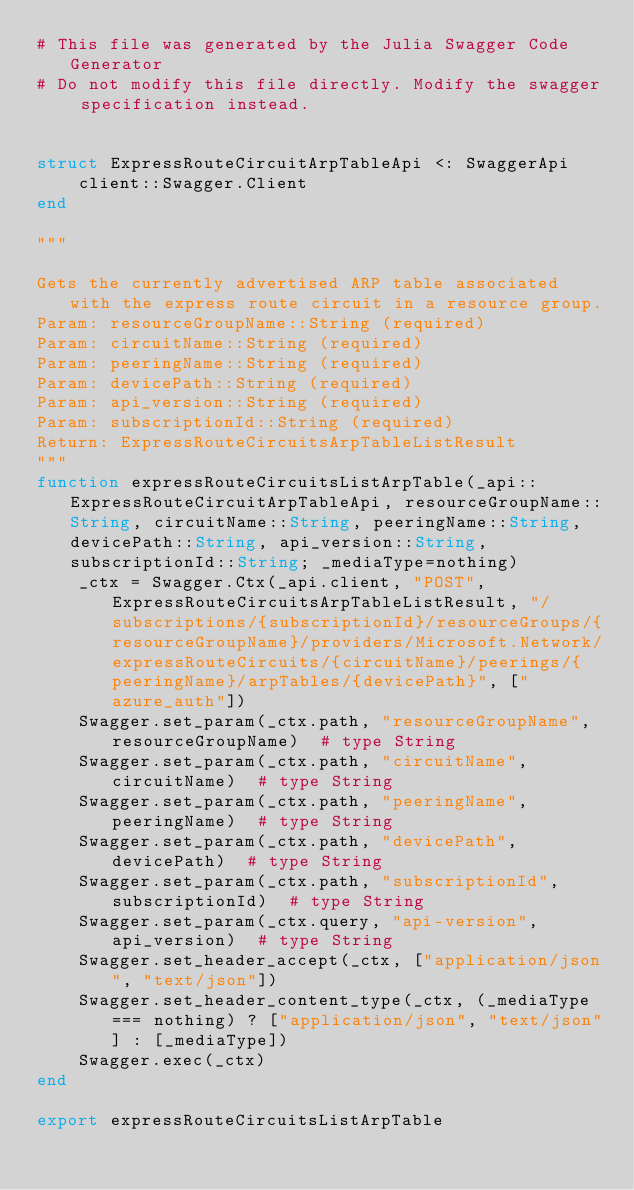<code> <loc_0><loc_0><loc_500><loc_500><_Julia_># This file was generated by the Julia Swagger Code Generator
# Do not modify this file directly. Modify the swagger specification instead.


struct ExpressRouteCircuitArpTableApi <: SwaggerApi
    client::Swagger.Client
end

"""

Gets the currently advertised ARP table associated with the express route circuit in a resource group.
Param: resourceGroupName::String (required)
Param: circuitName::String (required)
Param: peeringName::String (required)
Param: devicePath::String (required)
Param: api_version::String (required)
Param: subscriptionId::String (required)
Return: ExpressRouteCircuitsArpTableListResult
"""
function expressRouteCircuitsListArpTable(_api::ExpressRouteCircuitArpTableApi, resourceGroupName::String, circuitName::String, peeringName::String, devicePath::String, api_version::String, subscriptionId::String; _mediaType=nothing)
    _ctx = Swagger.Ctx(_api.client, "POST", ExpressRouteCircuitsArpTableListResult, "/subscriptions/{subscriptionId}/resourceGroups/{resourceGroupName}/providers/Microsoft.Network/expressRouteCircuits/{circuitName}/peerings/{peeringName}/arpTables/{devicePath}", ["azure_auth"])
    Swagger.set_param(_ctx.path, "resourceGroupName", resourceGroupName)  # type String
    Swagger.set_param(_ctx.path, "circuitName", circuitName)  # type String
    Swagger.set_param(_ctx.path, "peeringName", peeringName)  # type String
    Swagger.set_param(_ctx.path, "devicePath", devicePath)  # type String
    Swagger.set_param(_ctx.path, "subscriptionId", subscriptionId)  # type String
    Swagger.set_param(_ctx.query, "api-version", api_version)  # type String
    Swagger.set_header_accept(_ctx, ["application/json", "text/json"])
    Swagger.set_header_content_type(_ctx, (_mediaType === nothing) ? ["application/json", "text/json"] : [_mediaType])
    Swagger.exec(_ctx)
end

export expressRouteCircuitsListArpTable
</code> 